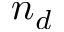Convert formula to latex. <formula><loc_0><loc_0><loc_500><loc_500>n _ { d }</formula> 